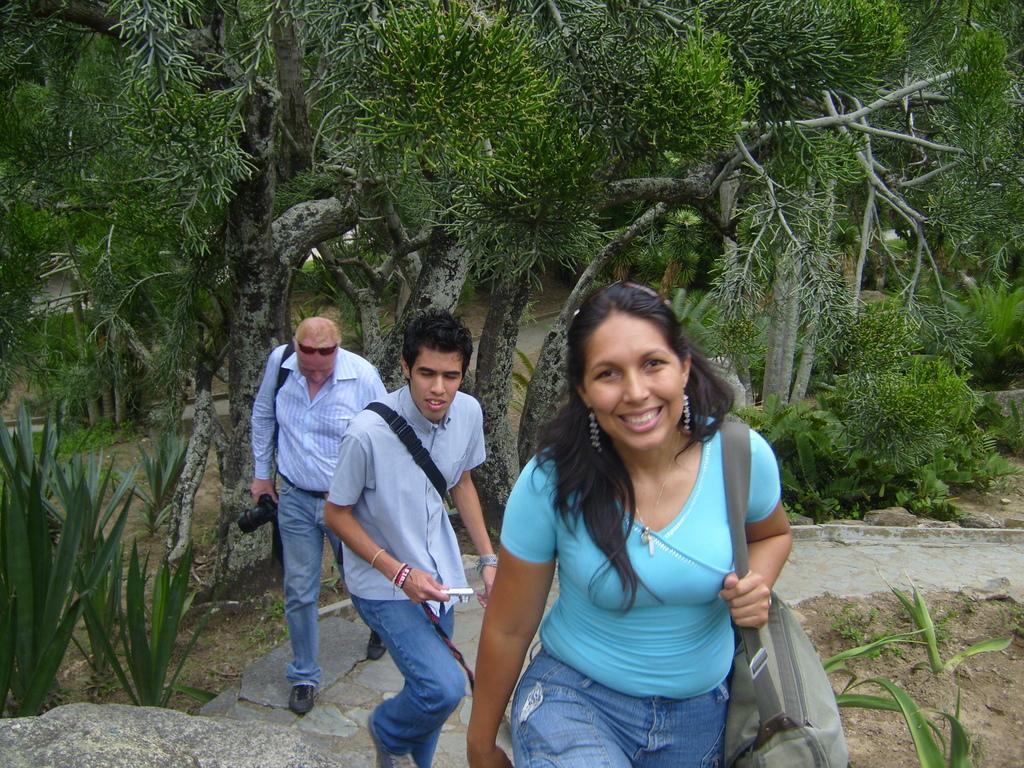Could you give a brief overview of what you see in this image? In this picture we can see two men and a woman walking, a woman is carrying a bag, a man on the left side is holding a camera, in the background there are some trees. 